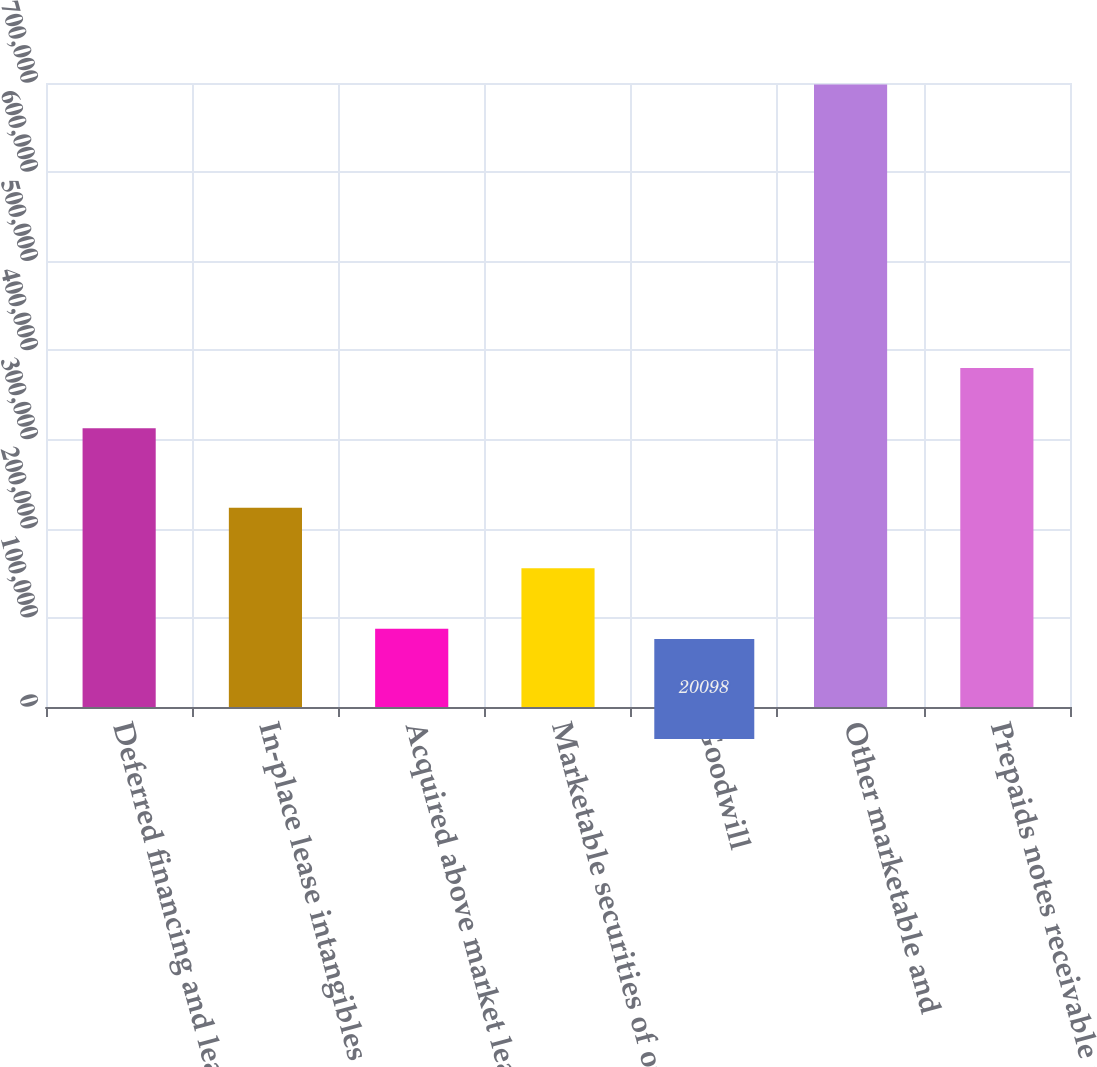Convert chart to OTSL. <chart><loc_0><loc_0><loc_500><loc_500><bar_chart><fcel>Deferred financing and lease<fcel>In-place lease intangibles net<fcel>Acquired above market lease<fcel>Marketable securities of our<fcel>Goodwill<fcel>Other marketable and<fcel>Prepaids notes receivable and<nl><fcel>312569<fcel>223548<fcel>87914.7<fcel>155731<fcel>20098<fcel>698265<fcel>380386<nl></chart> 